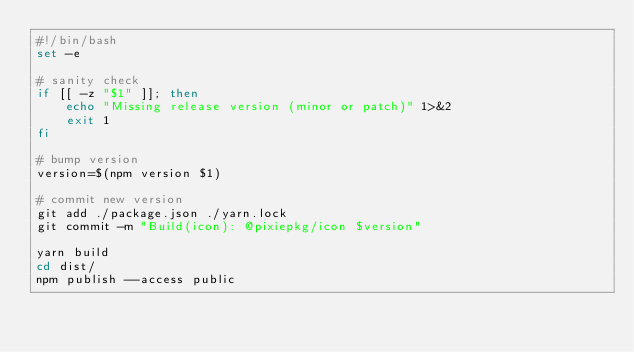Convert code to text. <code><loc_0><loc_0><loc_500><loc_500><_Bash_>#!/bin/bash
set -e

# sanity check
if [[ -z "$1" ]]; then
    echo "Missing release version (minor or patch)" 1>&2
    exit 1
fi

# bump version
version=$(npm version $1)

# commit new version
git add ./package.json ./yarn.lock
git commit -m "Build(icon): @pixiepkg/icon $version"

yarn build
cd dist/
npm publish --access public
</code> 